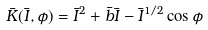Convert formula to latex. <formula><loc_0><loc_0><loc_500><loc_500>\bar { K } ( \bar { I } , \phi ) = { \bar { I } } ^ { 2 } + \bar { b } \bar { I } - { \bar { I } } ^ { 1 / 2 } \cos \phi</formula> 